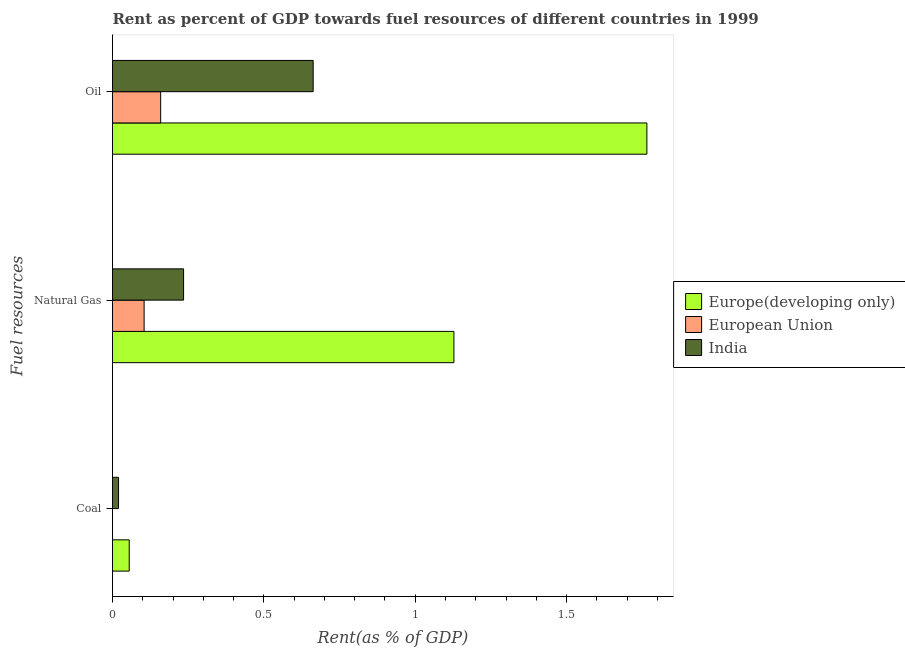How many different coloured bars are there?
Your response must be concise. 3. How many groups of bars are there?
Your answer should be compact. 3. Are the number of bars per tick equal to the number of legend labels?
Your answer should be compact. Yes. How many bars are there on the 2nd tick from the top?
Ensure brevity in your answer.  3. What is the label of the 2nd group of bars from the top?
Offer a very short reply. Natural Gas. What is the rent towards oil in European Union?
Your answer should be very brief. 0.16. Across all countries, what is the maximum rent towards natural gas?
Provide a short and direct response. 1.13. Across all countries, what is the minimum rent towards oil?
Keep it short and to the point. 0.16. In which country was the rent towards natural gas maximum?
Make the answer very short. Europe(developing only). In which country was the rent towards oil minimum?
Your answer should be compact. European Union. What is the total rent towards oil in the graph?
Provide a succinct answer. 2.59. What is the difference between the rent towards coal in European Union and that in Europe(developing only)?
Offer a very short reply. -0.06. What is the difference between the rent towards oil in India and the rent towards natural gas in European Union?
Provide a short and direct response. 0.56. What is the average rent towards coal per country?
Offer a very short reply. 0.03. What is the difference between the rent towards coal and rent towards natural gas in Europe(developing only)?
Your response must be concise. -1.07. What is the ratio of the rent towards oil in India to that in Europe(developing only)?
Your answer should be compact. 0.38. Is the rent towards coal in Europe(developing only) less than that in European Union?
Make the answer very short. No. What is the difference between the highest and the second highest rent towards oil?
Keep it short and to the point. 1.1. What is the difference between the highest and the lowest rent towards natural gas?
Your answer should be compact. 1.02. In how many countries, is the rent towards natural gas greater than the average rent towards natural gas taken over all countries?
Your answer should be very brief. 1. What does the 1st bar from the bottom in Coal represents?
Provide a succinct answer. Europe(developing only). Is it the case that in every country, the sum of the rent towards coal and rent towards natural gas is greater than the rent towards oil?
Give a very brief answer. No. Are all the bars in the graph horizontal?
Your answer should be compact. Yes. What is the difference between two consecutive major ticks on the X-axis?
Make the answer very short. 0.5. Does the graph contain any zero values?
Keep it short and to the point. No. Where does the legend appear in the graph?
Keep it short and to the point. Center right. How many legend labels are there?
Give a very brief answer. 3. How are the legend labels stacked?
Make the answer very short. Vertical. What is the title of the graph?
Ensure brevity in your answer.  Rent as percent of GDP towards fuel resources of different countries in 1999. What is the label or title of the X-axis?
Your answer should be very brief. Rent(as % of GDP). What is the label or title of the Y-axis?
Your response must be concise. Fuel resources. What is the Rent(as % of GDP) in Europe(developing only) in Coal?
Offer a very short reply. 0.06. What is the Rent(as % of GDP) of European Union in Coal?
Offer a very short reply. 7.968829103317441e-5. What is the Rent(as % of GDP) in India in Coal?
Provide a succinct answer. 0.02. What is the Rent(as % of GDP) of Europe(developing only) in Natural Gas?
Your answer should be very brief. 1.13. What is the Rent(as % of GDP) in European Union in Natural Gas?
Offer a very short reply. 0.1. What is the Rent(as % of GDP) in India in Natural Gas?
Your response must be concise. 0.23. What is the Rent(as % of GDP) in Europe(developing only) in Oil?
Provide a short and direct response. 1.77. What is the Rent(as % of GDP) in European Union in Oil?
Your answer should be very brief. 0.16. What is the Rent(as % of GDP) in India in Oil?
Keep it short and to the point. 0.66. Across all Fuel resources, what is the maximum Rent(as % of GDP) in Europe(developing only)?
Provide a short and direct response. 1.77. Across all Fuel resources, what is the maximum Rent(as % of GDP) of European Union?
Keep it short and to the point. 0.16. Across all Fuel resources, what is the maximum Rent(as % of GDP) in India?
Offer a terse response. 0.66. Across all Fuel resources, what is the minimum Rent(as % of GDP) in Europe(developing only)?
Your answer should be very brief. 0.06. Across all Fuel resources, what is the minimum Rent(as % of GDP) of European Union?
Make the answer very short. 7.968829103317441e-5. Across all Fuel resources, what is the minimum Rent(as % of GDP) in India?
Your response must be concise. 0.02. What is the total Rent(as % of GDP) of Europe(developing only) in the graph?
Give a very brief answer. 2.95. What is the total Rent(as % of GDP) of European Union in the graph?
Your response must be concise. 0.26. What is the total Rent(as % of GDP) in India in the graph?
Keep it short and to the point. 0.92. What is the difference between the Rent(as % of GDP) of Europe(developing only) in Coal and that in Natural Gas?
Your answer should be compact. -1.07. What is the difference between the Rent(as % of GDP) in European Union in Coal and that in Natural Gas?
Ensure brevity in your answer.  -0.1. What is the difference between the Rent(as % of GDP) in India in Coal and that in Natural Gas?
Offer a terse response. -0.21. What is the difference between the Rent(as % of GDP) in Europe(developing only) in Coal and that in Oil?
Give a very brief answer. -1.71. What is the difference between the Rent(as % of GDP) in European Union in Coal and that in Oil?
Your answer should be compact. -0.16. What is the difference between the Rent(as % of GDP) of India in Coal and that in Oil?
Offer a terse response. -0.64. What is the difference between the Rent(as % of GDP) in Europe(developing only) in Natural Gas and that in Oil?
Make the answer very short. -0.64. What is the difference between the Rent(as % of GDP) in European Union in Natural Gas and that in Oil?
Your response must be concise. -0.05. What is the difference between the Rent(as % of GDP) of India in Natural Gas and that in Oil?
Provide a short and direct response. -0.43. What is the difference between the Rent(as % of GDP) in Europe(developing only) in Coal and the Rent(as % of GDP) in European Union in Natural Gas?
Your answer should be very brief. -0.05. What is the difference between the Rent(as % of GDP) in Europe(developing only) in Coal and the Rent(as % of GDP) in India in Natural Gas?
Offer a very short reply. -0.18. What is the difference between the Rent(as % of GDP) of European Union in Coal and the Rent(as % of GDP) of India in Natural Gas?
Keep it short and to the point. -0.23. What is the difference between the Rent(as % of GDP) of Europe(developing only) in Coal and the Rent(as % of GDP) of European Union in Oil?
Your answer should be very brief. -0.1. What is the difference between the Rent(as % of GDP) of Europe(developing only) in Coal and the Rent(as % of GDP) of India in Oil?
Provide a succinct answer. -0.61. What is the difference between the Rent(as % of GDP) of European Union in Coal and the Rent(as % of GDP) of India in Oil?
Give a very brief answer. -0.66. What is the difference between the Rent(as % of GDP) in Europe(developing only) in Natural Gas and the Rent(as % of GDP) in European Union in Oil?
Provide a short and direct response. 0.97. What is the difference between the Rent(as % of GDP) of Europe(developing only) in Natural Gas and the Rent(as % of GDP) of India in Oil?
Your answer should be very brief. 0.46. What is the difference between the Rent(as % of GDP) of European Union in Natural Gas and the Rent(as % of GDP) of India in Oil?
Keep it short and to the point. -0.56. What is the average Rent(as % of GDP) of Europe(developing only) per Fuel resources?
Your answer should be compact. 0.98. What is the average Rent(as % of GDP) in European Union per Fuel resources?
Give a very brief answer. 0.09. What is the average Rent(as % of GDP) of India per Fuel resources?
Ensure brevity in your answer.  0.31. What is the difference between the Rent(as % of GDP) of Europe(developing only) and Rent(as % of GDP) of European Union in Coal?
Offer a very short reply. 0.06. What is the difference between the Rent(as % of GDP) of Europe(developing only) and Rent(as % of GDP) of India in Coal?
Give a very brief answer. 0.04. What is the difference between the Rent(as % of GDP) in European Union and Rent(as % of GDP) in India in Coal?
Ensure brevity in your answer.  -0.02. What is the difference between the Rent(as % of GDP) of Europe(developing only) and Rent(as % of GDP) of European Union in Natural Gas?
Keep it short and to the point. 1.02. What is the difference between the Rent(as % of GDP) of Europe(developing only) and Rent(as % of GDP) of India in Natural Gas?
Keep it short and to the point. 0.89. What is the difference between the Rent(as % of GDP) in European Union and Rent(as % of GDP) in India in Natural Gas?
Provide a succinct answer. -0.13. What is the difference between the Rent(as % of GDP) of Europe(developing only) and Rent(as % of GDP) of European Union in Oil?
Offer a very short reply. 1.61. What is the difference between the Rent(as % of GDP) of Europe(developing only) and Rent(as % of GDP) of India in Oil?
Ensure brevity in your answer.  1.1. What is the difference between the Rent(as % of GDP) in European Union and Rent(as % of GDP) in India in Oil?
Give a very brief answer. -0.5. What is the ratio of the Rent(as % of GDP) of Europe(developing only) in Coal to that in Natural Gas?
Provide a succinct answer. 0.05. What is the ratio of the Rent(as % of GDP) of European Union in Coal to that in Natural Gas?
Keep it short and to the point. 0. What is the ratio of the Rent(as % of GDP) in India in Coal to that in Natural Gas?
Your answer should be very brief. 0.09. What is the ratio of the Rent(as % of GDP) in Europe(developing only) in Coal to that in Oil?
Provide a succinct answer. 0.03. What is the ratio of the Rent(as % of GDP) in European Union in Coal to that in Oil?
Make the answer very short. 0. What is the ratio of the Rent(as % of GDP) in India in Coal to that in Oil?
Keep it short and to the point. 0.03. What is the ratio of the Rent(as % of GDP) in Europe(developing only) in Natural Gas to that in Oil?
Provide a short and direct response. 0.64. What is the ratio of the Rent(as % of GDP) in European Union in Natural Gas to that in Oil?
Your answer should be compact. 0.66. What is the ratio of the Rent(as % of GDP) in India in Natural Gas to that in Oil?
Your response must be concise. 0.35. What is the difference between the highest and the second highest Rent(as % of GDP) of Europe(developing only)?
Your response must be concise. 0.64. What is the difference between the highest and the second highest Rent(as % of GDP) of European Union?
Ensure brevity in your answer.  0.05. What is the difference between the highest and the second highest Rent(as % of GDP) of India?
Provide a short and direct response. 0.43. What is the difference between the highest and the lowest Rent(as % of GDP) of Europe(developing only)?
Provide a short and direct response. 1.71. What is the difference between the highest and the lowest Rent(as % of GDP) in European Union?
Your answer should be very brief. 0.16. What is the difference between the highest and the lowest Rent(as % of GDP) of India?
Your response must be concise. 0.64. 